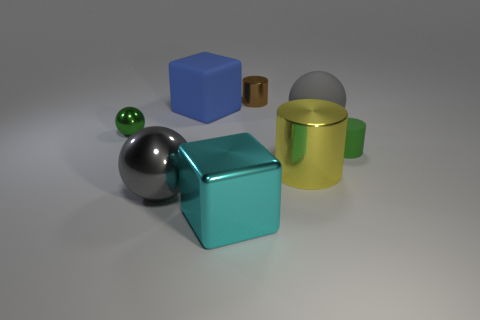Subtract 1 cylinders. How many cylinders are left? 2 Add 2 big matte balls. How many objects exist? 10 Subtract all cylinders. How many objects are left? 5 Add 7 small green rubber objects. How many small green rubber objects exist? 8 Subtract 0 purple cylinders. How many objects are left? 8 Subtract all green matte cylinders. Subtract all large blue metal blocks. How many objects are left? 7 Add 8 small brown metal things. How many small brown metal things are left? 9 